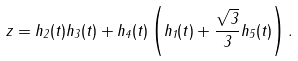Convert formula to latex. <formula><loc_0><loc_0><loc_500><loc_500>z = h _ { 2 } ( t ) h _ { 3 } ( t ) + h _ { 4 } ( t ) \left ( h _ { 1 } ( t ) + \frac { \sqrt { 3 } } { 3 } h _ { 5 } ( t ) \right ) .</formula> 